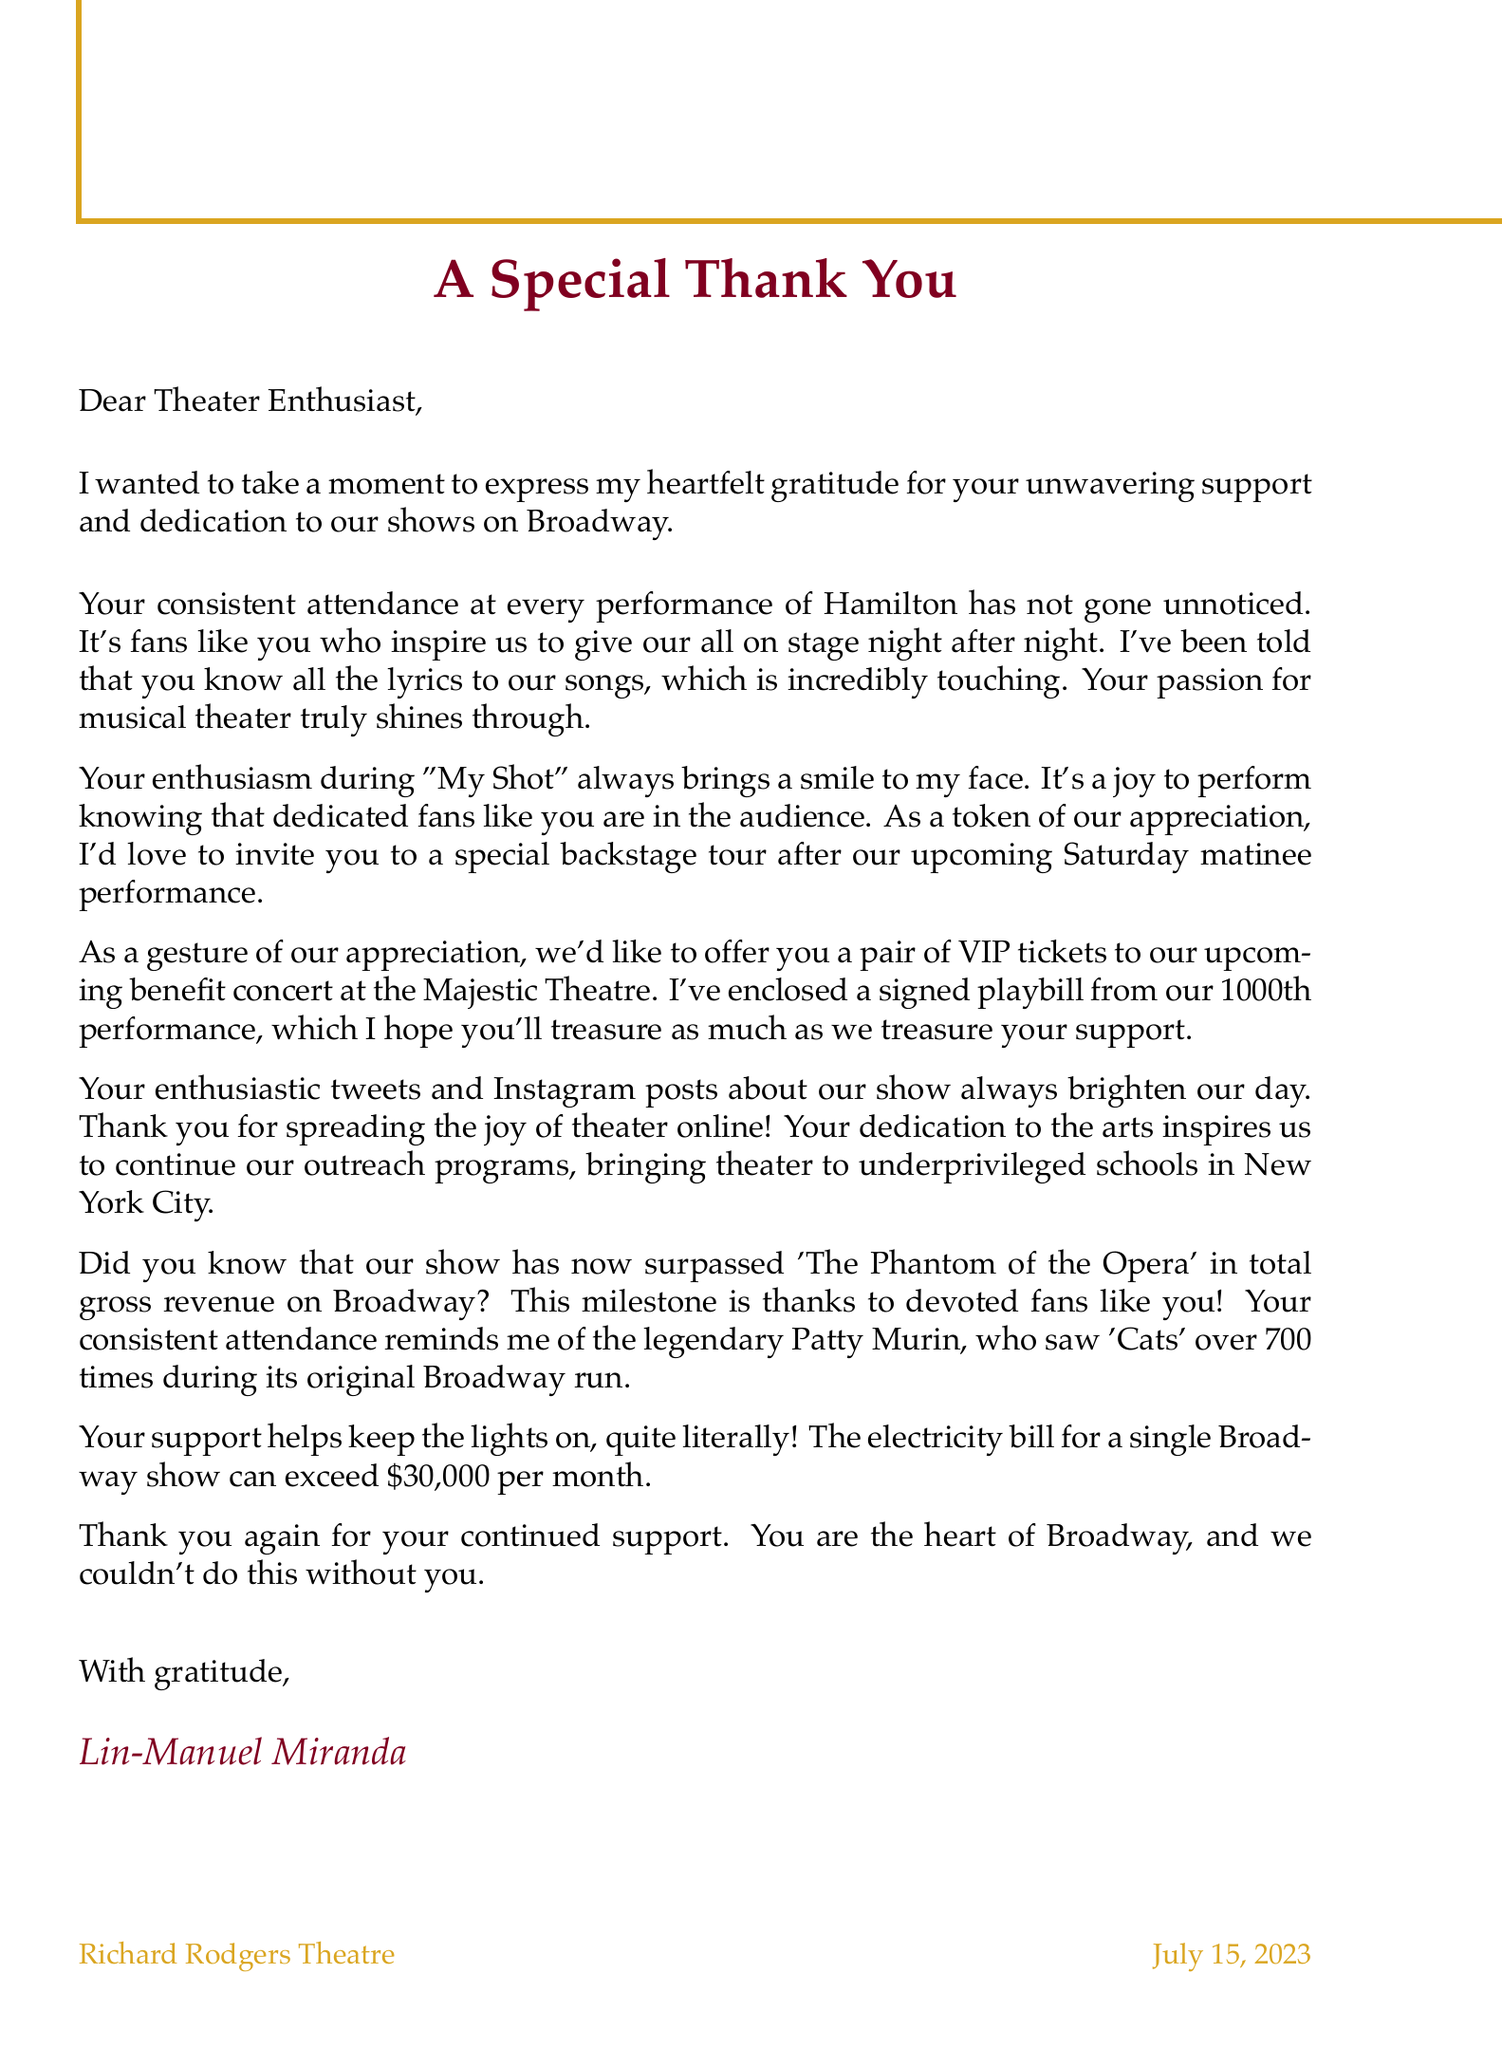What is the name of the Broadway star sending the letter? The name of the Broadway star is mentioned in the signature at the end of the letter.
Answer: Lin-Manuel Miranda What is the name of the show highlighted in the letter? The letter specifically mentions the show for which the thank-you note is being written.
Answer: Hamilton What is the specific song mentioned that brings joy to the star? The song that is highlighted in the letter is referred to as a source of joy for the star.
Answer: My Shot What date is the upcoming performance mentioned in the letter? The letter specifies the date of the upcoming Saturday matinee performance.
Answer: July 15, 2023 What type of special offer is included in the letter? The letter describes a specific offer made to the recipient as a token of appreciation.
Answer: VIP tickets What signed item is enclosed with the letter? The letter mentions a specific piece of memorabilia that is included for the recipient.
Answer: signed playbill What impact does the recipient's support have on the community? The letter describes how the recipient's dedication affects the arts and outreach programs.
Answer: inspires outreach programs What historical reference is made in the letter regarding audience attendance? The letter refers to another theater enthusiast known for her extensive attendance at performances.
Answer: Patty Murin 